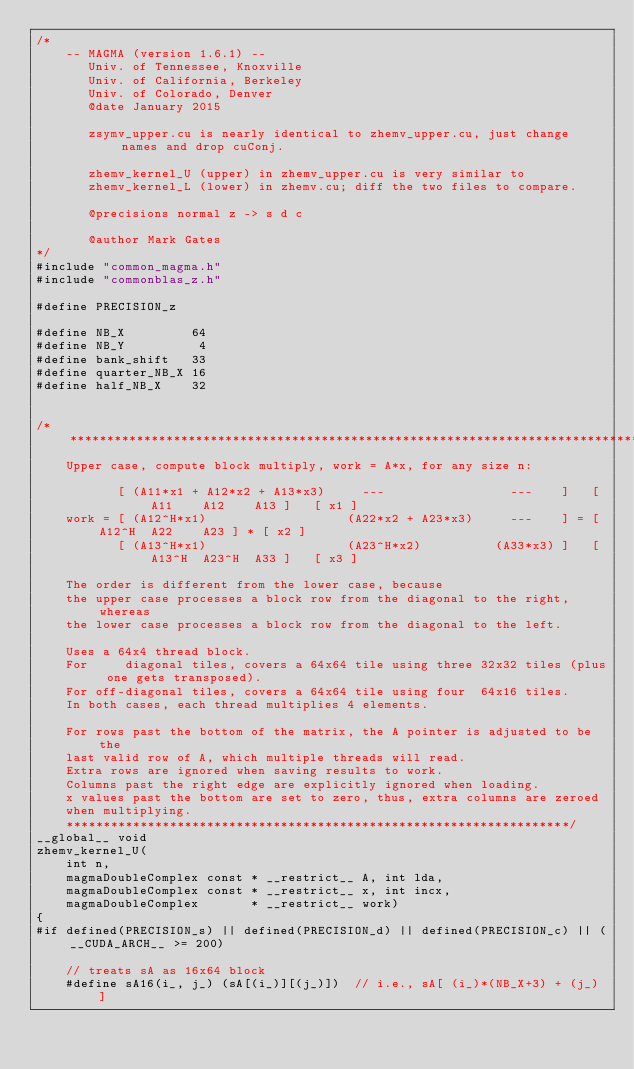Convert code to text. <code><loc_0><loc_0><loc_500><loc_500><_Cuda_>/*
    -- MAGMA (version 1.6.1) --
       Univ. of Tennessee, Knoxville
       Univ. of California, Berkeley
       Univ. of Colorado, Denver
       @date January 2015
       
       zsymv_upper.cu is nearly identical to zhemv_upper.cu, just change names and drop cuConj.
       
       zhemv_kernel_U (upper) in zhemv_upper.cu is very similar to
       zhemv_kernel_L (lower) in zhemv.cu; diff the two files to compare.
       
       @precisions normal z -> s d c
       
       @author Mark Gates
*/
#include "common_magma.h"
#include "commonblas_z.h"

#define PRECISION_z

#define NB_X         64
#define NB_Y          4
#define bank_shift   33
#define quarter_NB_X 16
#define half_NB_X    32


/*******************************************************************************
    Upper case, compute block multiply, work = A*x, for any size n:
    
           [ (A11*x1 + A12*x2 + A13*x3)     ---                 ---    ]   [ A11    A12    A13 ]   [ x1 ]
    work = [ (A12^H*x1)                   (A22*x2 + A23*x3)     ---    ] = [ A12^H  A22    A23 ] * [ x2 ]
           [ (A13^H*x1)                   (A23^H*x2)          (A33*x3) ]   [ A13^H  A23^H  A33 ]   [ x3 ]
    
    The order is different from the lower case, because
    the upper case processes a block row from the diagonal to the right, whereas
    the lower case processes a block row from the diagonal to the left.
    
    Uses a 64x4 thread block.
    For     diagonal tiles, covers a 64x64 tile using three 32x32 tiles (plus one gets transposed).
    For off-diagonal tiles, covers a 64x64 tile using four  64x16 tiles.
    In both cases, each thread multiplies 4 elements.
    
    For rows past the bottom of the matrix, the A pointer is adjusted to be the
    last valid row of A, which multiple threads will read.
    Extra rows are ignored when saving results to work.
    Columns past the right edge are explicitly ignored when loading.
    x values past the bottom are set to zero, thus, extra columns are zeroed
    when multiplying.
    ********************************************************************/
__global__ void
zhemv_kernel_U(
    int n,
    magmaDoubleComplex const * __restrict__ A, int lda,
    magmaDoubleComplex const * __restrict__ x, int incx,
    magmaDoubleComplex       * __restrict__ work)
{
#if defined(PRECISION_s) || defined(PRECISION_d) || defined(PRECISION_c) || (__CUDA_ARCH__ >= 200)

    // treats sA as 16x64 block
    #define sA16(i_, j_) (sA[(i_)][(j_)])  // i.e., sA[ (i_)*(NB_X+3) + (j_) ]
    </code> 